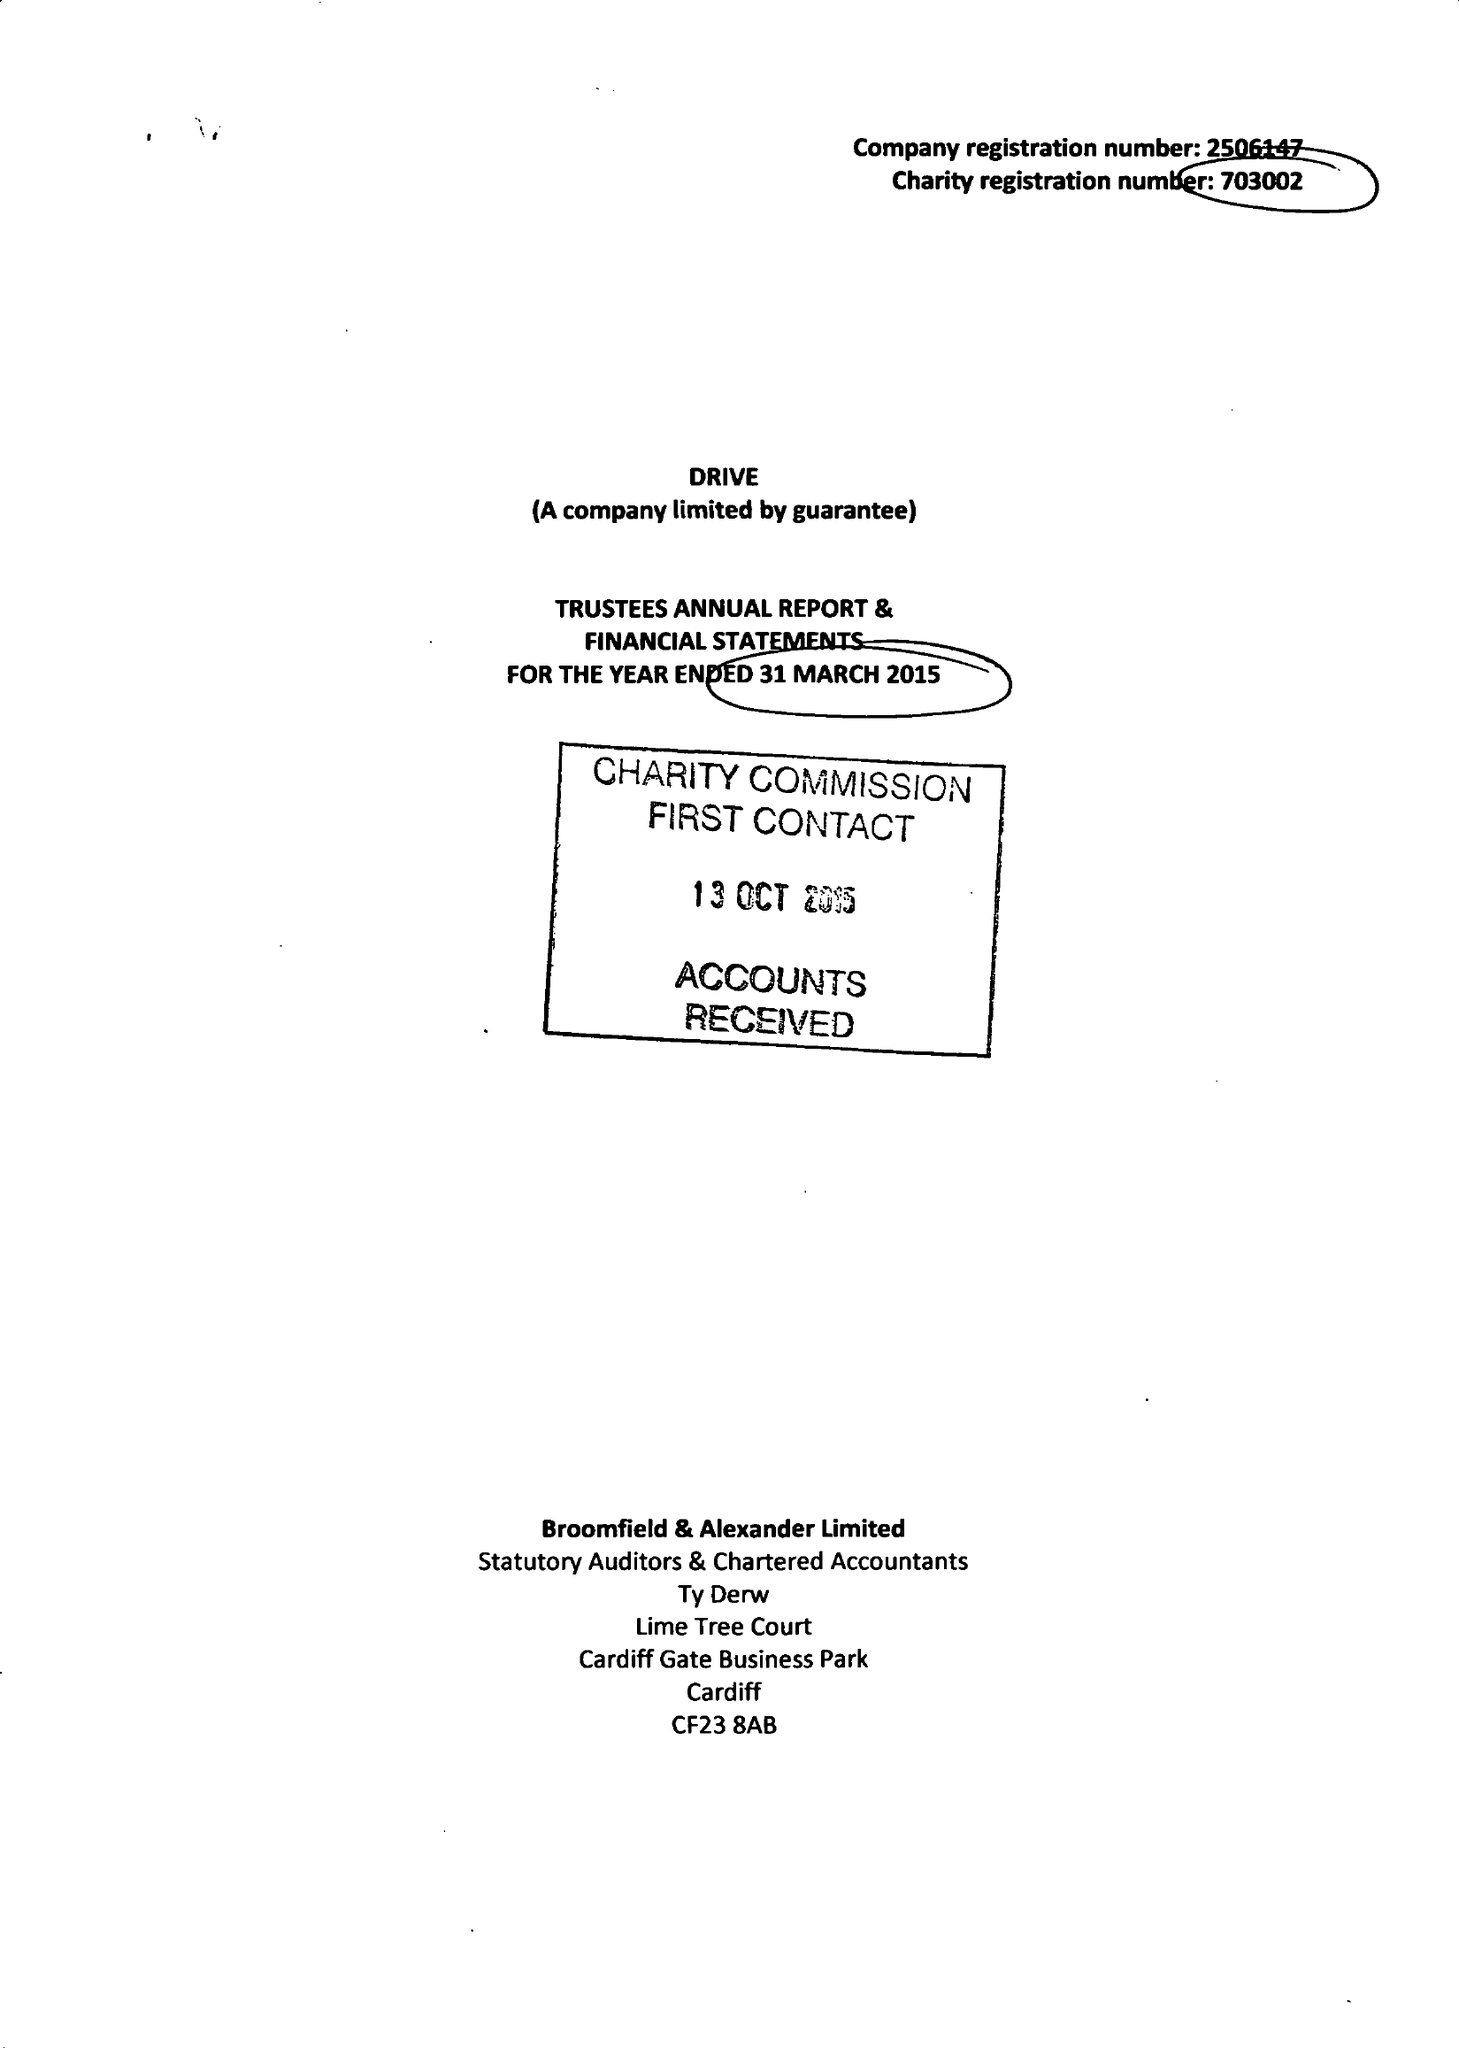What is the value for the address__street_line?
Answer the question using a single word or phrase. CEFN COED 